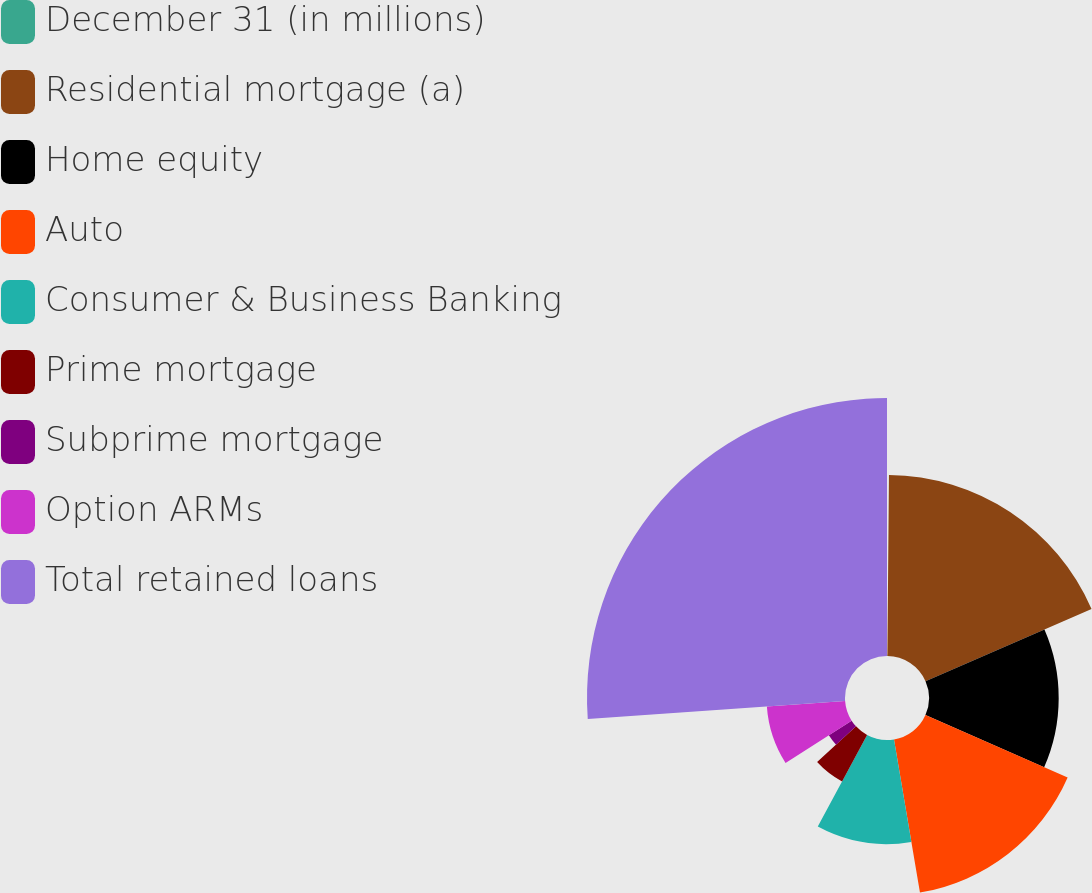<chart> <loc_0><loc_0><loc_500><loc_500><pie_chart><fcel>December 31 (in millions)<fcel>Residential mortgage (a)<fcel>Home equity<fcel>Auto<fcel>Consumer & Business Banking<fcel>Prime mortgage<fcel>Subprime mortgage<fcel>Option ARMs<fcel>Total retained loans<nl><fcel>0.14%<fcel>18.33%<fcel>13.13%<fcel>15.73%<fcel>10.53%<fcel>5.34%<fcel>2.74%<fcel>7.94%<fcel>26.12%<nl></chart> 